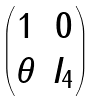Convert formula to latex. <formula><loc_0><loc_0><loc_500><loc_500>\begin{pmatrix} 1 & 0 \\ \theta & I _ { 4 } \\ \end{pmatrix}</formula> 